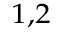Convert formula to latex. <formula><loc_0><loc_0><loc_500><loc_500>^ { 1 , 2 }</formula> 